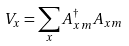Convert formula to latex. <formula><loc_0><loc_0><loc_500><loc_500>V _ { x } = \sum _ { x } A ^ { \dagger } _ { x m } A _ { x m }</formula> 